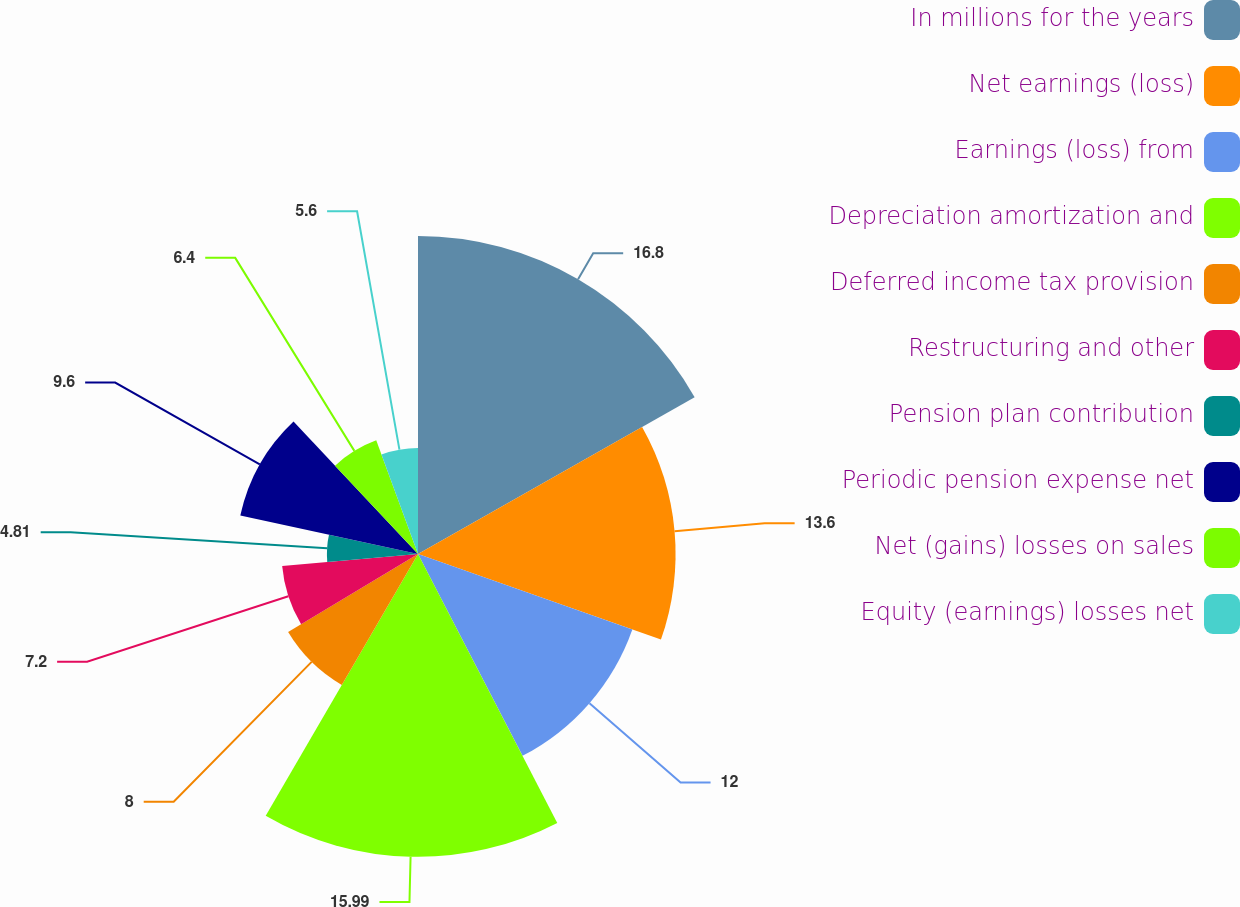<chart> <loc_0><loc_0><loc_500><loc_500><pie_chart><fcel>In millions for the years<fcel>Net earnings (loss)<fcel>Earnings (loss) from<fcel>Depreciation amortization and<fcel>Deferred income tax provision<fcel>Restructuring and other<fcel>Pension plan contribution<fcel>Periodic pension expense net<fcel>Net (gains) losses on sales<fcel>Equity (earnings) losses net<nl><fcel>16.79%<fcel>13.6%<fcel>12.0%<fcel>15.99%<fcel>8.0%<fcel>7.2%<fcel>4.81%<fcel>9.6%<fcel>6.4%<fcel>5.6%<nl></chart> 